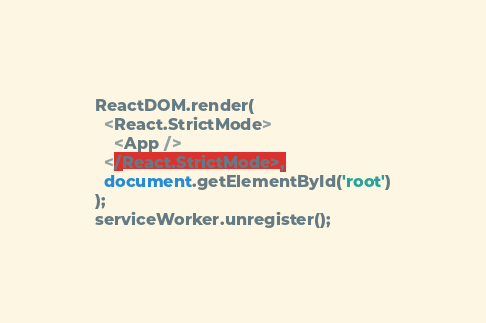Convert code to text. <code><loc_0><loc_0><loc_500><loc_500><_JavaScript_>ReactDOM.render(
  <React.StrictMode>
    <App />
  </React.StrictMode>,
  document.getElementById('root')
);
serviceWorker.unregister();
</code> 